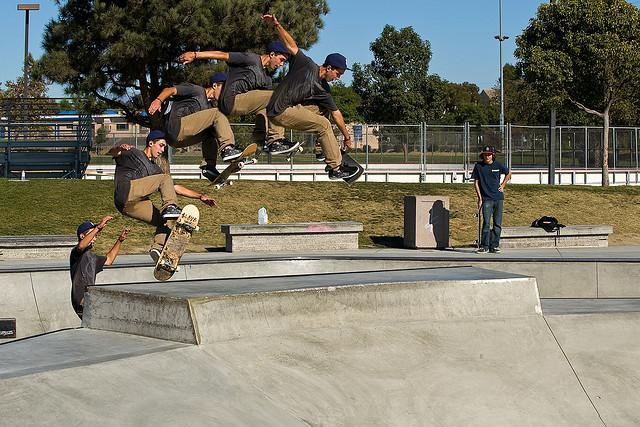How many people wearing tan pants and black shirts are seen here?

Choices:
A) two
B) five
C) one
D) six one 